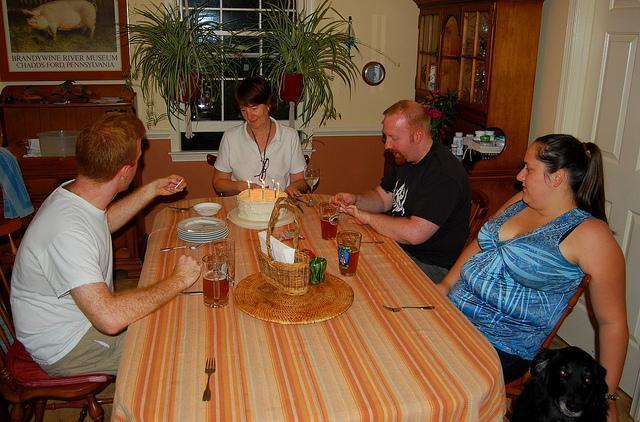How many potted plants are in the photo?
Give a very brief answer. 2. How many people are there?
Give a very brief answer. 4. How many people are wearing an orange shirt?
Give a very brief answer. 0. 